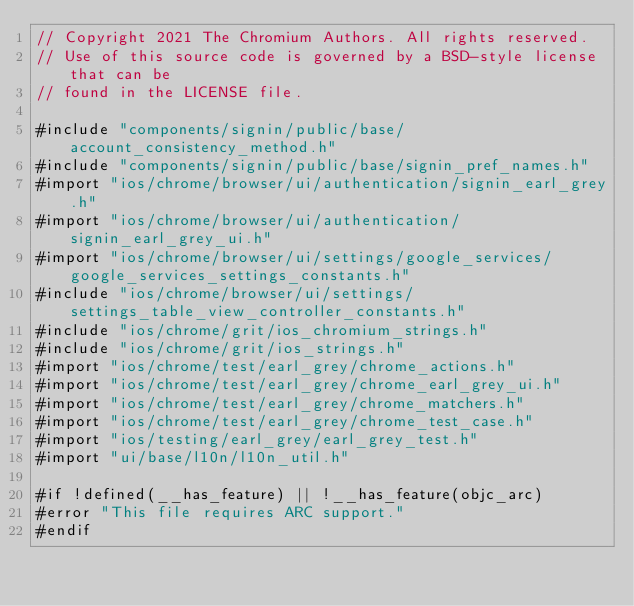Convert code to text. <code><loc_0><loc_0><loc_500><loc_500><_ObjectiveC_>// Copyright 2021 The Chromium Authors. All rights reserved.
// Use of this source code is governed by a BSD-style license that can be
// found in the LICENSE file.

#include "components/signin/public/base/account_consistency_method.h"
#include "components/signin/public/base/signin_pref_names.h"
#import "ios/chrome/browser/ui/authentication/signin_earl_grey.h"
#import "ios/chrome/browser/ui/authentication/signin_earl_grey_ui.h"
#import "ios/chrome/browser/ui/settings/google_services/google_services_settings_constants.h"
#include "ios/chrome/browser/ui/settings/settings_table_view_controller_constants.h"
#include "ios/chrome/grit/ios_chromium_strings.h"
#include "ios/chrome/grit/ios_strings.h"
#import "ios/chrome/test/earl_grey/chrome_actions.h"
#import "ios/chrome/test/earl_grey/chrome_earl_grey_ui.h"
#import "ios/chrome/test/earl_grey/chrome_matchers.h"
#import "ios/chrome/test/earl_grey/chrome_test_case.h"
#import "ios/testing/earl_grey/earl_grey_test.h"
#import "ui/base/l10n/l10n_util.h"

#if !defined(__has_feature) || !__has_feature(objc_arc)
#error "This file requires ARC support."
#endif
</code> 